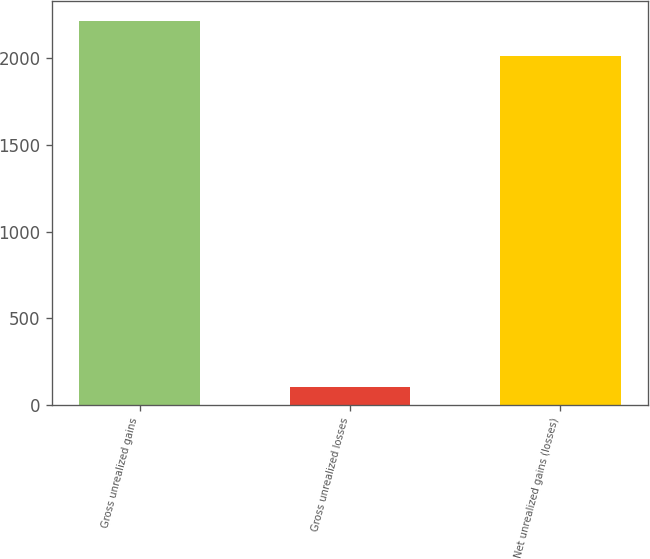<chart> <loc_0><loc_0><loc_500><loc_500><bar_chart><fcel>Gross unrealized gains<fcel>Gross unrealized losses<fcel>Net unrealized gains (losses)<nl><fcel>2214.3<fcel>107<fcel>2013<nl></chart> 